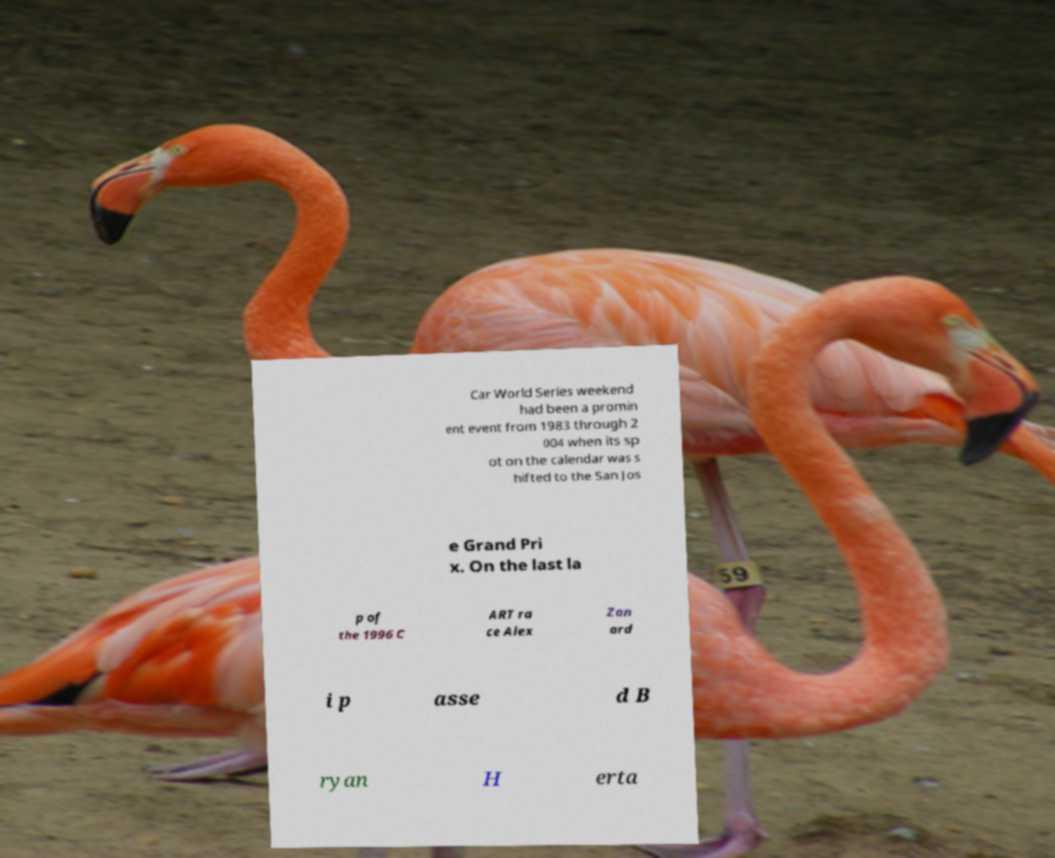Could you extract and type out the text from this image? Car World Series weekend had been a promin ent event from 1983 through 2 004 when its sp ot on the calendar was s hifted to the San Jos e Grand Pri x. On the last la p of the 1996 C ART ra ce Alex Zan ard i p asse d B ryan H erta 